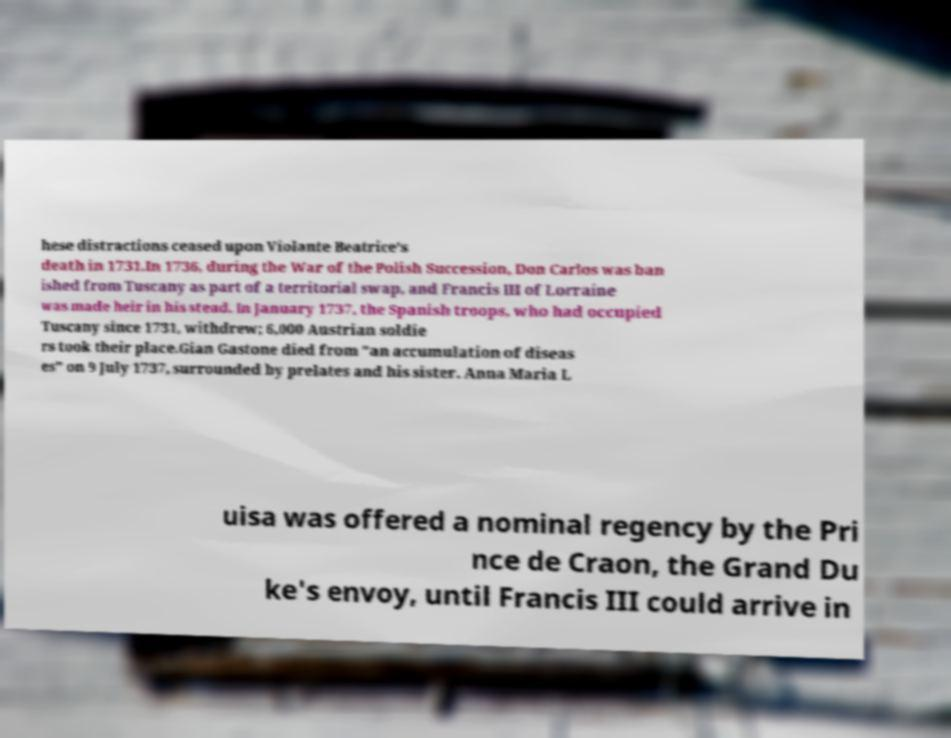Can you accurately transcribe the text from the provided image for me? hese distractions ceased upon Violante Beatrice's death in 1731.In 1736, during the War of the Polish Succession, Don Carlos was ban ished from Tuscany as part of a territorial swap, and Francis III of Lorraine was made heir in his stead. In January 1737, the Spanish troops, who had occupied Tuscany since 1731, withdrew; 6,000 Austrian soldie rs took their place.Gian Gastone died from "an accumulation of diseas es" on 9 July 1737, surrounded by prelates and his sister. Anna Maria L uisa was offered a nominal regency by the Pri nce de Craon, the Grand Du ke's envoy, until Francis III could arrive in 